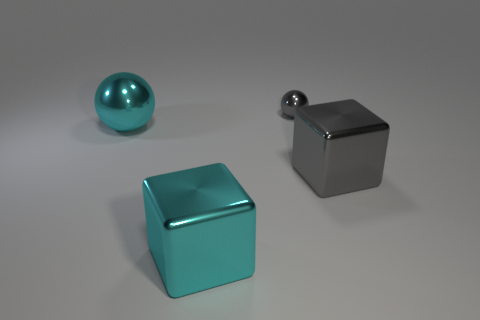Are there any other things that have the same size as the gray ball?
Offer a terse response. No. Do the cyan shiny cube and the gray metallic sphere have the same size?
Make the answer very short. No. Is the color of the large block that is left of the large gray shiny thing the same as the big metallic ball?
Provide a short and direct response. Yes. What is the material of the big thing that is the same color as the tiny shiny thing?
Your response must be concise. Metal. Are there fewer big cyan shiny things on the left side of the cyan block than cyan metal objects?
Your response must be concise. Yes. Is the number of gray metal balls on the left side of the cyan shiny sphere less than the number of gray balls that are on the left side of the tiny gray sphere?
Ensure brevity in your answer.  No. How many cubes are either tiny objects or big metal objects?
Ensure brevity in your answer.  2. Does the big cyan thing in front of the gray block have the same material as the sphere to the right of the big metal ball?
Offer a very short reply. Yes. What is the shape of the cyan shiny object that is the same size as the cyan sphere?
Provide a succinct answer. Cube. How many other things are there of the same color as the tiny object?
Make the answer very short. 1. 